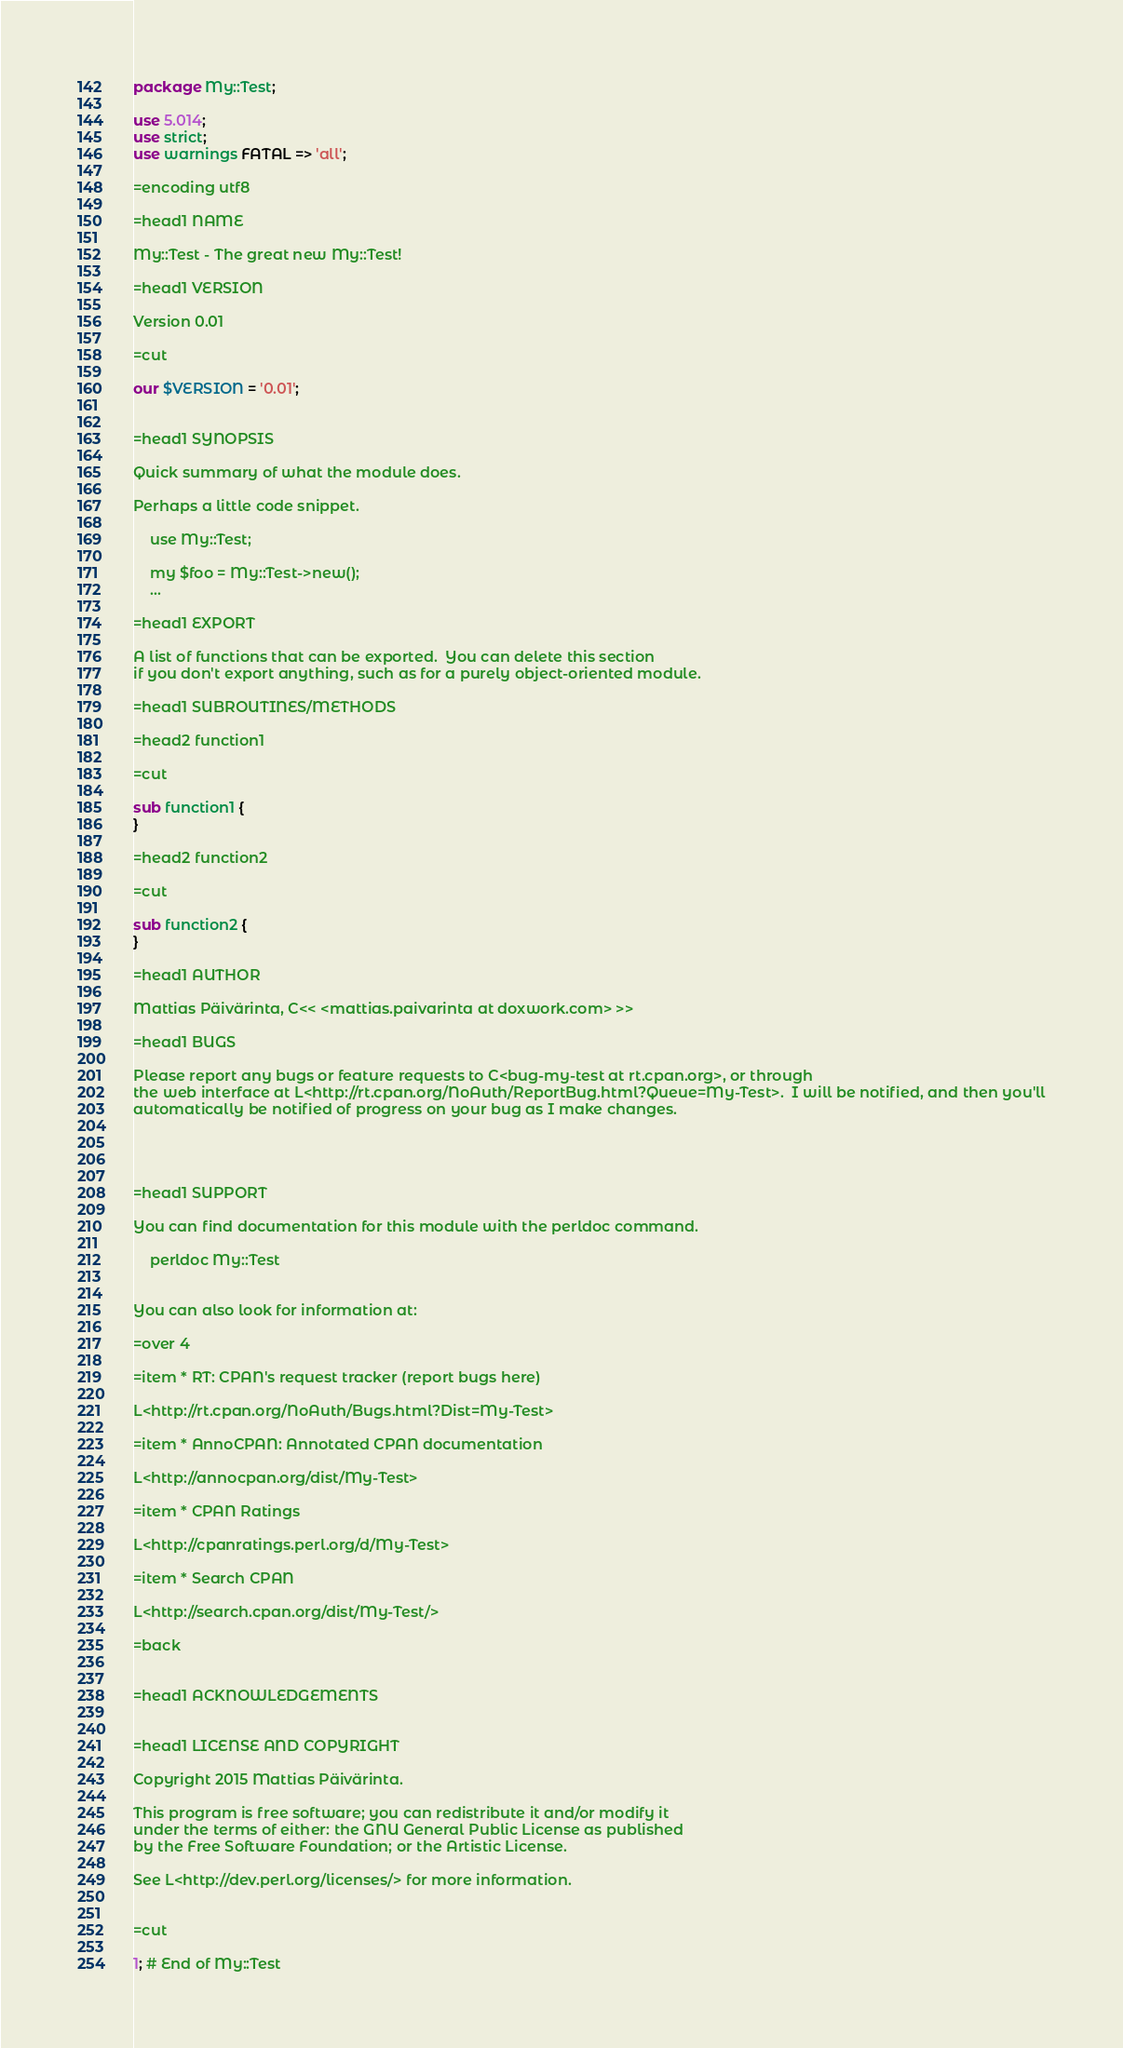<code> <loc_0><loc_0><loc_500><loc_500><_Perl_>package My::Test;

use 5.014;
use strict;
use warnings FATAL => 'all';

=encoding utf8

=head1 NAME

My::Test - The great new My::Test!

=head1 VERSION

Version 0.01

=cut

our $VERSION = '0.01';


=head1 SYNOPSIS

Quick summary of what the module does.

Perhaps a little code snippet.

    use My::Test;

    my $foo = My::Test->new();
    ...

=head1 EXPORT

A list of functions that can be exported.  You can delete this section
if you don't export anything, such as for a purely object-oriented module.

=head1 SUBROUTINES/METHODS

=head2 function1

=cut

sub function1 {
}

=head2 function2

=cut

sub function2 {
}

=head1 AUTHOR

Mattias Päivärinta, C<< <mattias.paivarinta at doxwork.com> >>

=head1 BUGS

Please report any bugs or feature requests to C<bug-my-test at rt.cpan.org>, or through
the web interface at L<http://rt.cpan.org/NoAuth/ReportBug.html?Queue=My-Test>.  I will be notified, and then you'll
automatically be notified of progress on your bug as I make changes.




=head1 SUPPORT

You can find documentation for this module with the perldoc command.

    perldoc My::Test


You can also look for information at:

=over 4

=item * RT: CPAN's request tracker (report bugs here)

L<http://rt.cpan.org/NoAuth/Bugs.html?Dist=My-Test>

=item * AnnoCPAN: Annotated CPAN documentation

L<http://annocpan.org/dist/My-Test>

=item * CPAN Ratings

L<http://cpanratings.perl.org/d/My-Test>

=item * Search CPAN

L<http://search.cpan.org/dist/My-Test/>

=back


=head1 ACKNOWLEDGEMENTS


=head1 LICENSE AND COPYRIGHT

Copyright 2015 Mattias Päivärinta.

This program is free software; you can redistribute it and/or modify it
under the terms of either: the GNU General Public License as published
by the Free Software Foundation; or the Artistic License.

See L<http://dev.perl.org/licenses/> for more information.


=cut

1; # End of My::Test
</code> 